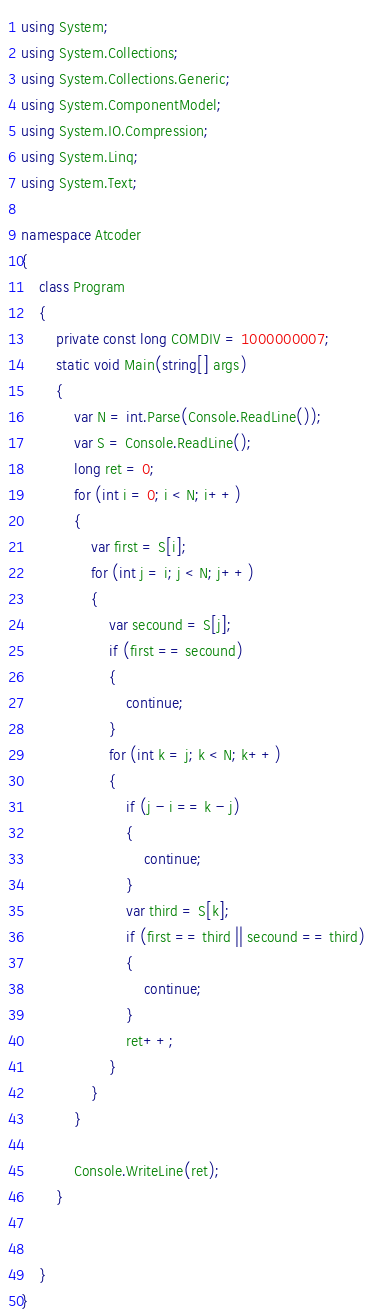Convert code to text. <code><loc_0><loc_0><loc_500><loc_500><_C#_>using System;
using System.Collections;
using System.Collections.Generic;
using System.ComponentModel;
using System.IO.Compression;
using System.Linq;
using System.Text;

namespace Atcoder
{
    class Program
    {
        private const long COMDIV = 1000000007;
        static void Main(string[] args)
        {
            var N = int.Parse(Console.ReadLine());
            var S = Console.ReadLine();
            long ret = 0;
            for (int i = 0; i < N; i++)
            {
                var first = S[i];
                for (int j = i; j < N; j++)
                {
                    var secound = S[j];
                    if (first == secound)
                    {
                        continue;
                    }
                    for (int k = j; k < N; k++)
                    {
                        if (j - i == k - j)
                        {
                            continue;
                        }
                        var third = S[k];
                        if (first == third || secound == third)
                        {
                            continue;
                        }
                        ret++;
                    }
                }
            }

            Console.WriteLine(ret);
        }
        

    }
}</code> 